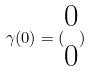Convert formula to latex. <formula><loc_0><loc_0><loc_500><loc_500>\gamma ( 0 ) = ( \begin{matrix} 0 \\ 0 \end{matrix} )</formula> 